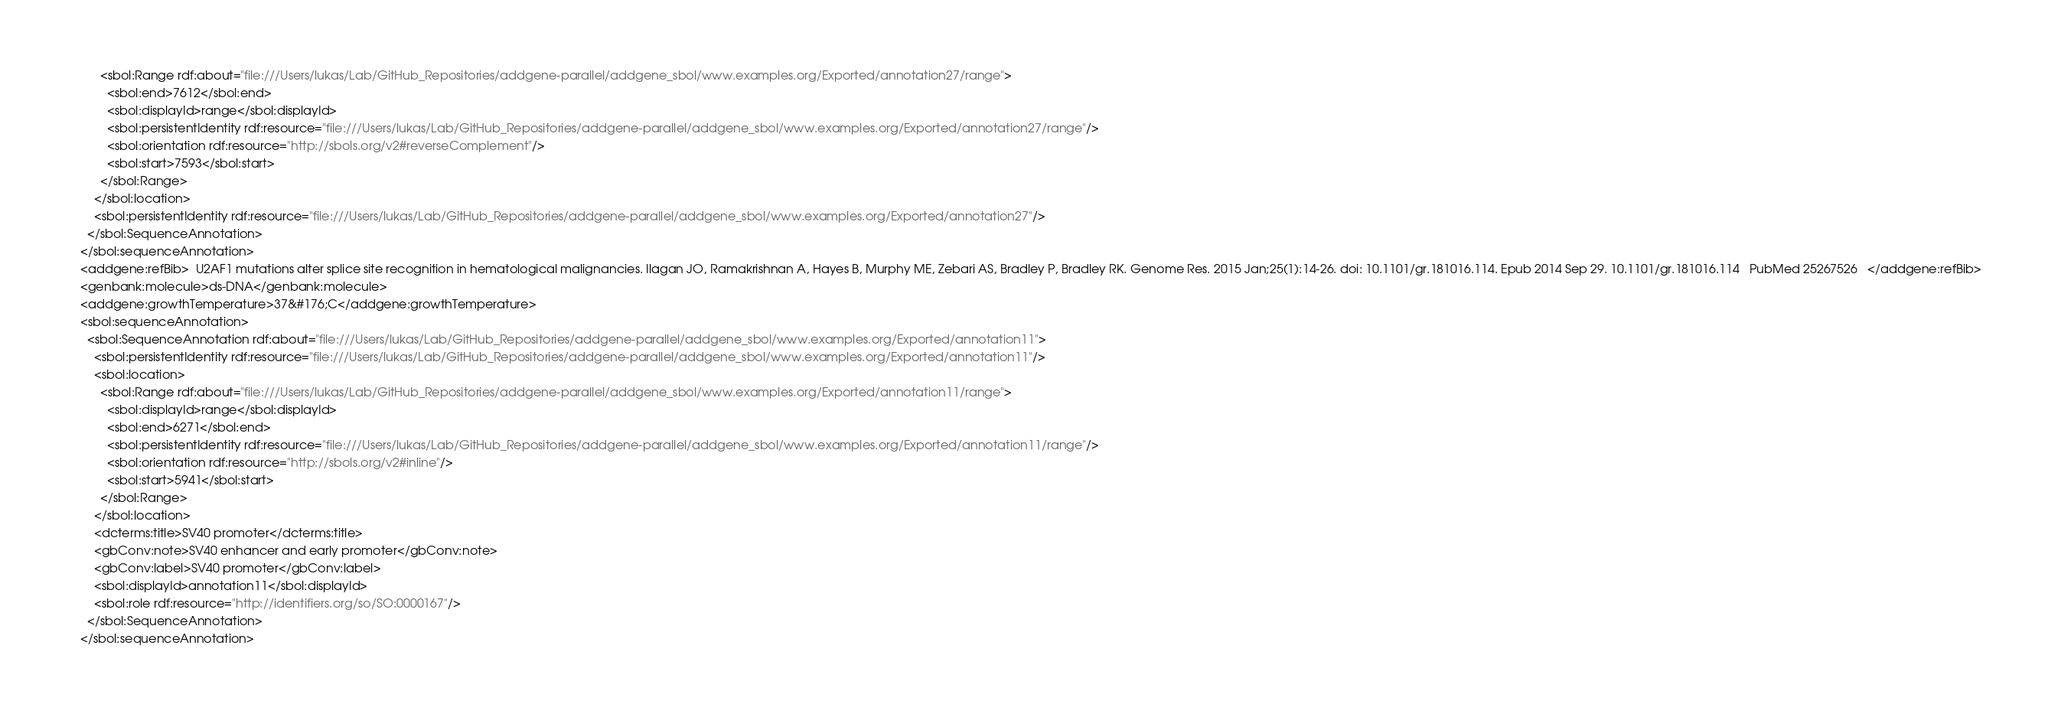<code> <loc_0><loc_0><loc_500><loc_500><_XML_>          <sbol:Range rdf:about="file:///Users/lukas/Lab/GitHub_Repositories/addgene-parallel/addgene_sbol/www.examples.org/Exported/annotation27/range">
            <sbol:end>7612</sbol:end>
            <sbol:displayId>range</sbol:displayId>
            <sbol:persistentIdentity rdf:resource="file:///Users/lukas/Lab/GitHub_Repositories/addgene-parallel/addgene_sbol/www.examples.org/Exported/annotation27/range"/>
            <sbol:orientation rdf:resource="http://sbols.org/v2#reverseComplement"/>
            <sbol:start>7593</sbol:start>
          </sbol:Range>
        </sbol:location>
        <sbol:persistentIdentity rdf:resource="file:///Users/lukas/Lab/GitHub_Repositories/addgene-parallel/addgene_sbol/www.examples.org/Exported/annotation27"/>
      </sbol:SequenceAnnotation>
    </sbol:sequenceAnnotation>
    <addgene:refBib>  U2AF1 mutations alter splice site recognition in hematological malignancies. Ilagan JO, Ramakrishnan A, Hayes B, Murphy ME, Zebari AS, Bradley P, Bradley RK. Genome Res. 2015 Jan;25(1):14-26. doi: 10.1101/gr.181016.114. Epub 2014 Sep 29. 10.1101/gr.181016.114   PubMed 25267526   </addgene:refBib>
    <genbank:molecule>ds-DNA</genbank:molecule>
    <addgene:growthTemperature>37&#176;C</addgene:growthTemperature>
    <sbol:sequenceAnnotation>
      <sbol:SequenceAnnotation rdf:about="file:///Users/lukas/Lab/GitHub_Repositories/addgene-parallel/addgene_sbol/www.examples.org/Exported/annotation11">
        <sbol:persistentIdentity rdf:resource="file:///Users/lukas/Lab/GitHub_Repositories/addgene-parallel/addgene_sbol/www.examples.org/Exported/annotation11"/>
        <sbol:location>
          <sbol:Range rdf:about="file:///Users/lukas/Lab/GitHub_Repositories/addgene-parallel/addgene_sbol/www.examples.org/Exported/annotation11/range">
            <sbol:displayId>range</sbol:displayId>
            <sbol:end>6271</sbol:end>
            <sbol:persistentIdentity rdf:resource="file:///Users/lukas/Lab/GitHub_Repositories/addgene-parallel/addgene_sbol/www.examples.org/Exported/annotation11/range"/>
            <sbol:orientation rdf:resource="http://sbols.org/v2#inline"/>
            <sbol:start>5941</sbol:start>
          </sbol:Range>
        </sbol:location>
        <dcterms:title>SV40 promoter</dcterms:title>
        <gbConv:note>SV40 enhancer and early promoter</gbConv:note>
        <gbConv:label>SV40 promoter</gbConv:label>
        <sbol:displayId>annotation11</sbol:displayId>
        <sbol:role rdf:resource="http://identifiers.org/so/SO:0000167"/>
      </sbol:SequenceAnnotation>
    </sbol:sequenceAnnotation></code> 